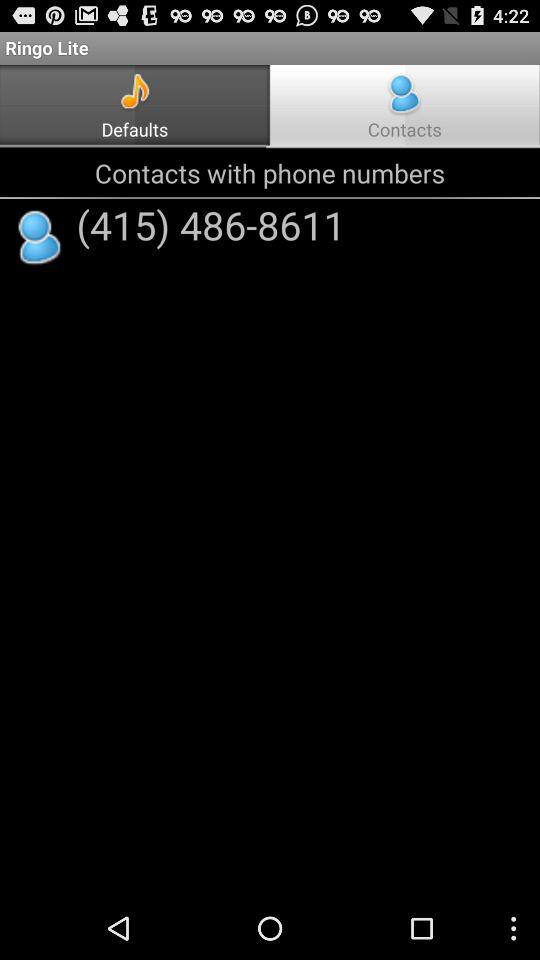How can we add new contacts?
When the provided information is insufficient, respond with <no answer>. <no answer> 